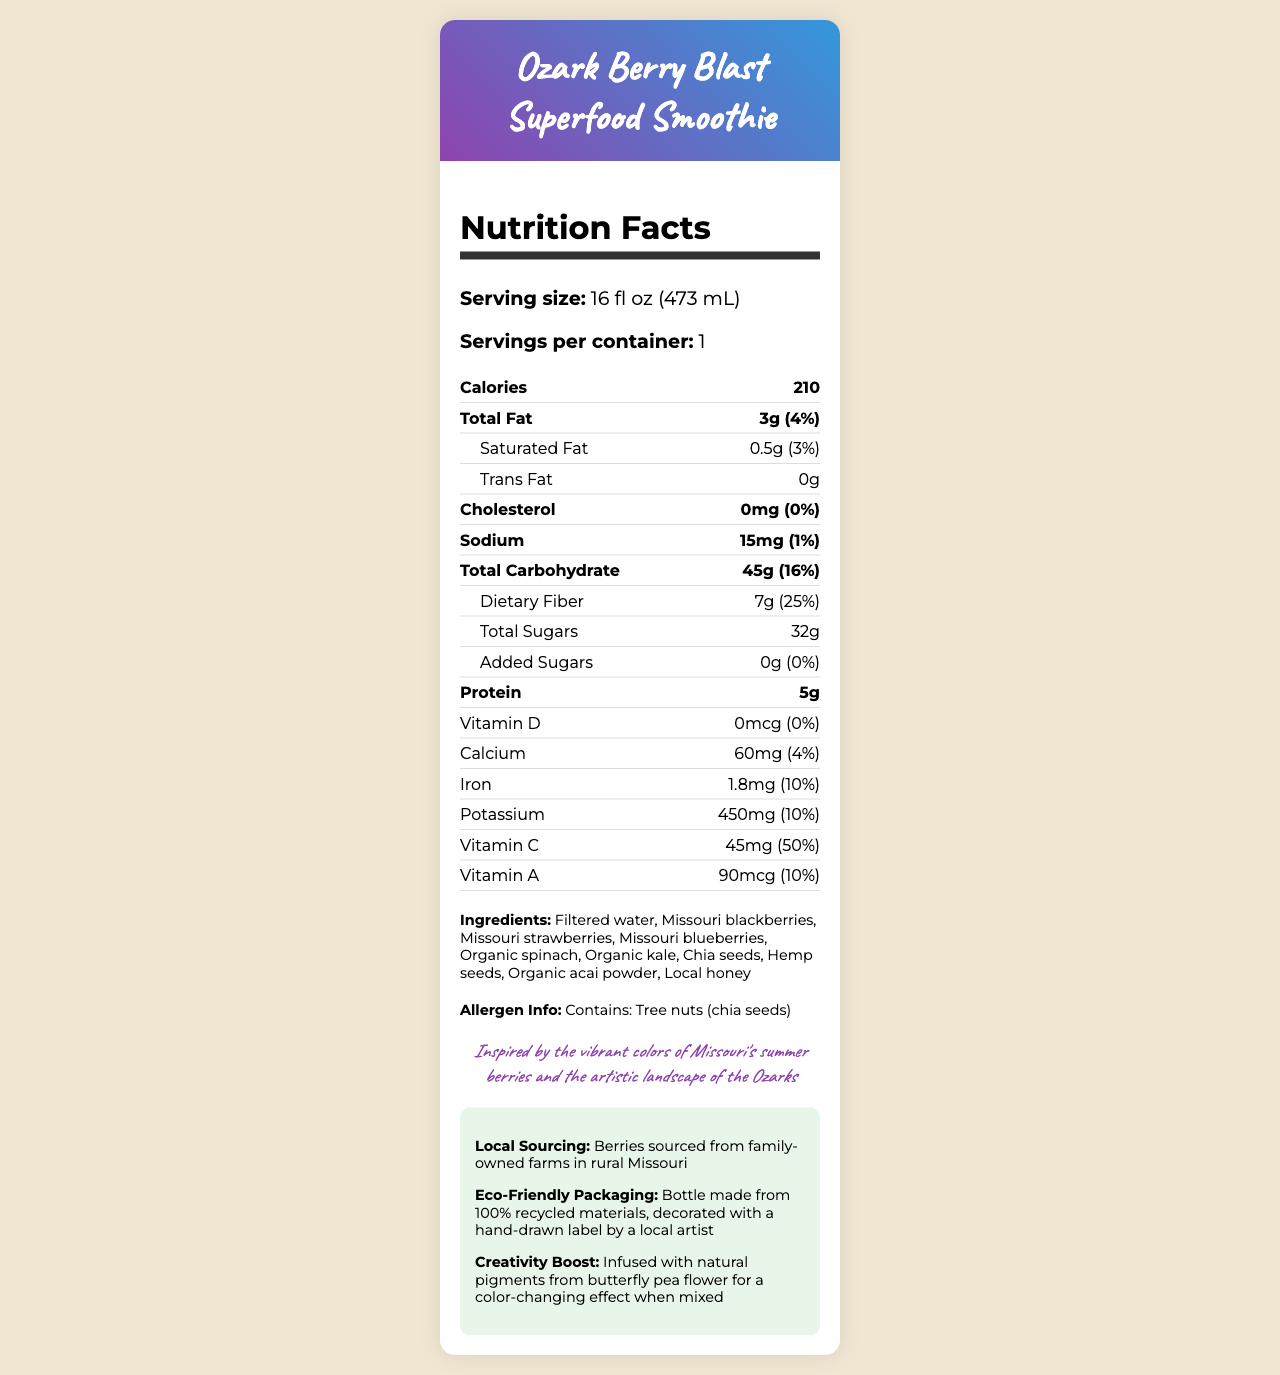what is the serving size of the Ozark Berry Blast Superfood Smoothie? The document lists the serving size directly under "Serving size" with the measurement given in both fluid ounces and milliliters.
Answer: 16 fl oz (473 mL) how many calories are there in one serving? The document states "Calories" under the main nutrition facts, with the value being 210 for one serving.
Answer: 210 what is the daily value percentage for dietary fiber? The daily value percentage for dietary fiber is listed next to its amount in the nutrition facts.
Answer: 25% how much protein does the smoothie contain? The amount of protein can be found under the main nutrients section labeled as "Protein."
Answer: 5g what is the source of the superfood smoothie’s purple color? The document mentions that the smoothie is "Infused with natural pigments from butterfly pea flower for a color-changing effect when mixed."
Answer: Butterfly Pea Flower which vitamin has the highest daily value percentage in the smoothie? A. Vitamin C B. Vitamin A C. Vitamin D D. Calcium The document shows that Vitamin C has a daily value of 50%, which is the highest among other listed vitamins and minerals.
Answer: A. Vitamin C which ingredient is NOT part of the Ozark Berry Blast Superfood Smoothie? A. Organic spinach B. Missouri blueberries C. Missouri raspberries D. Filtered water The ingredient list includes organic spinach, Missouri blueberries, and filtered water, but not Missouri raspberries.
Answer: C. Missouri raspberries does the smoothie contain added sugars? The document states that the amount of added sugars is 0g.
Answer: No are there any allergens in the smoothie? The document lists "Contains: Tree nuts (chia seeds)" under allergen information.
Answer: Yes summarize the main idea of the document The summary description breaks down the main components and highlights of the entire document.
Answer: The document provides a detailed nutrition facts label for the Ozark Berry Blast Superfood Smoothie, which is made using local Missouri berries and other healthy ingredients. It includes information about serving size, calories, nutritional content, ingredients, and allergen information. Additionally, the document highlights that the berries are sourced from family-owned farms in rural Missouri and that the product uses eco-friendly packaging. who are the family-owned farms sourcing the berries? The document mentions that the berries are sourced from family-owned farms in rural Missouri but does not provide specific names or details about these farms.
Answer: Not enough information 